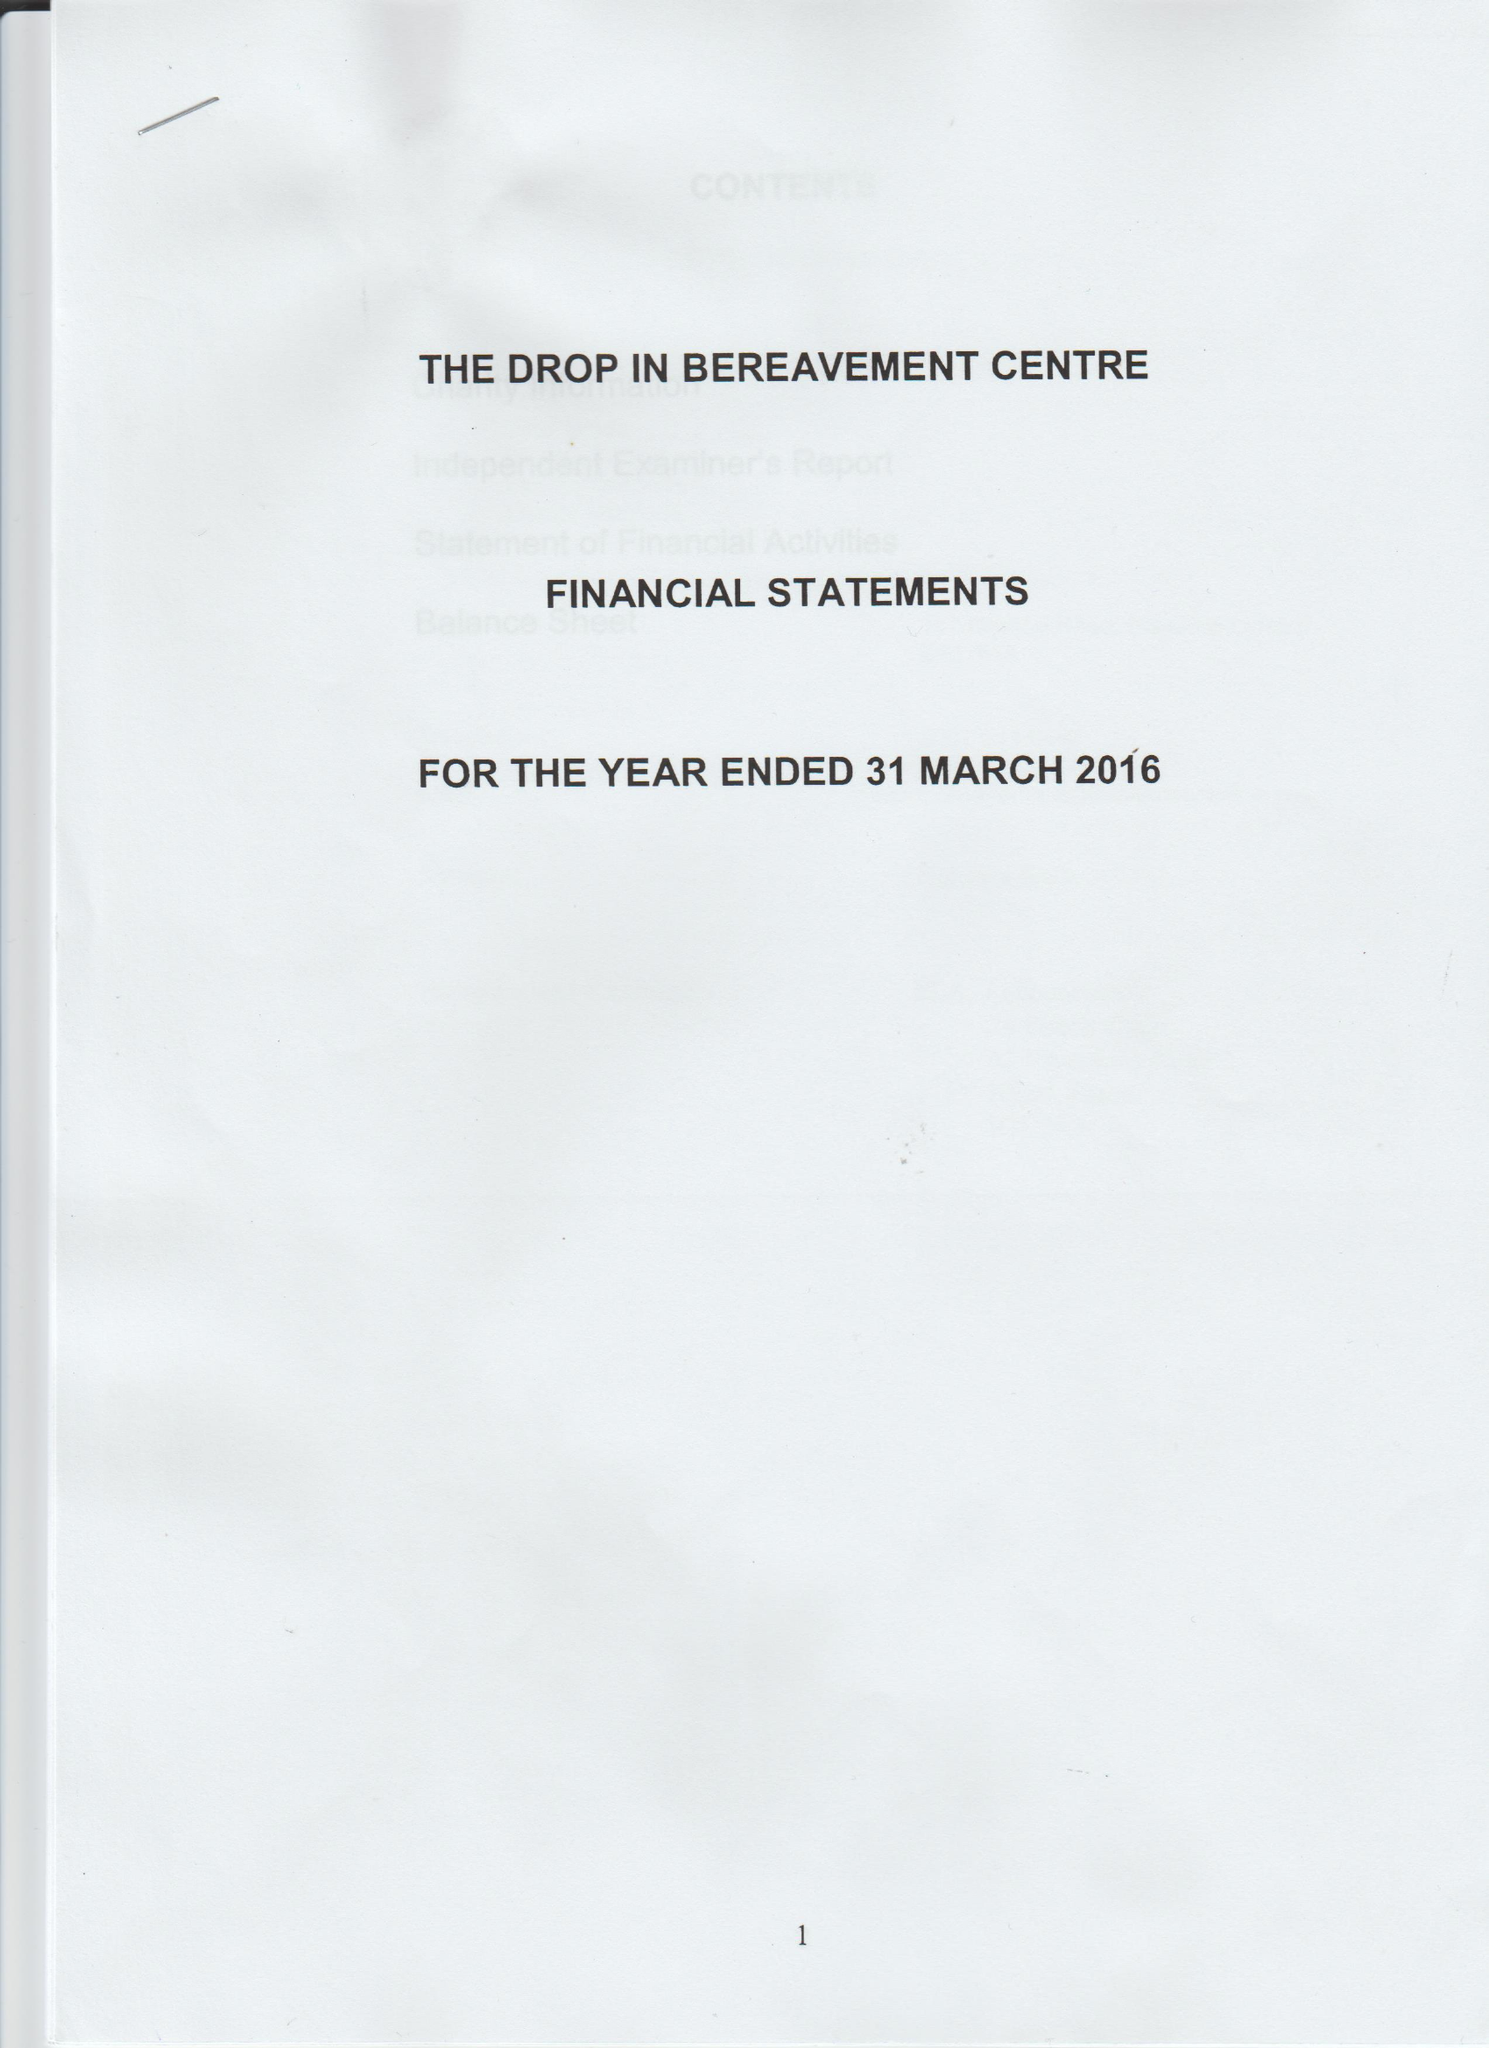What is the value for the address__postcode?
Answer the question using a single word or phrase. E13 0HA 